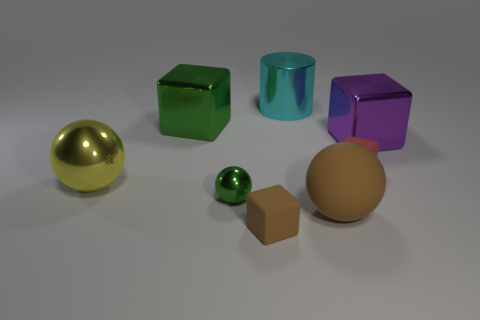There is a tiny thing that is the same color as the large rubber ball; what is it made of?
Make the answer very short. Rubber. There is a matte thing that is the same color as the rubber ball; what is its shape?
Your answer should be very brief. Cube. How many large yellow objects are there?
Offer a terse response. 1. What number of cubes are either brown rubber objects or large cyan metallic things?
Offer a very short reply. 1. What number of tiny green things are in front of the big metal object on the right side of the cylinder that is to the left of the big purple thing?
Keep it short and to the point. 1. There is a rubber thing that is the same size as the purple metal block; what is its color?
Ensure brevity in your answer.  Brown. How many other things are the same color as the shiny cylinder?
Your answer should be compact. 0. Are there more big blocks that are to the right of the brown ball than tiny red metal cylinders?
Provide a succinct answer. Yes. Are the big cyan cylinder and the brown cube made of the same material?
Provide a succinct answer. No. What number of objects are green objects that are in front of the large yellow metal sphere or balls?
Ensure brevity in your answer.  3. 